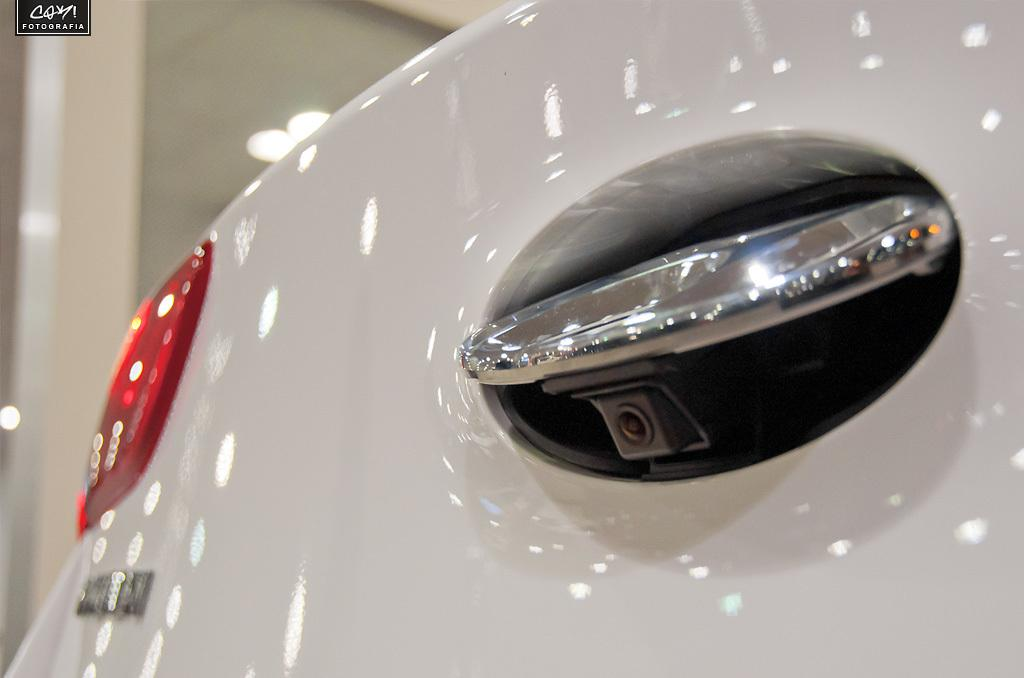What part of the car is visible in the image? The back side of a car is visible in the image. What feature can be seen on the back of the car? The car has a reverse camera and a tail lamp. Is there any text or logo visible in the image? There is a watermark in the top left corner of the image. How far is the farm from the car in the image? There is no farm present in the image, so it is not possible to determine the distance between the car and a farm. 